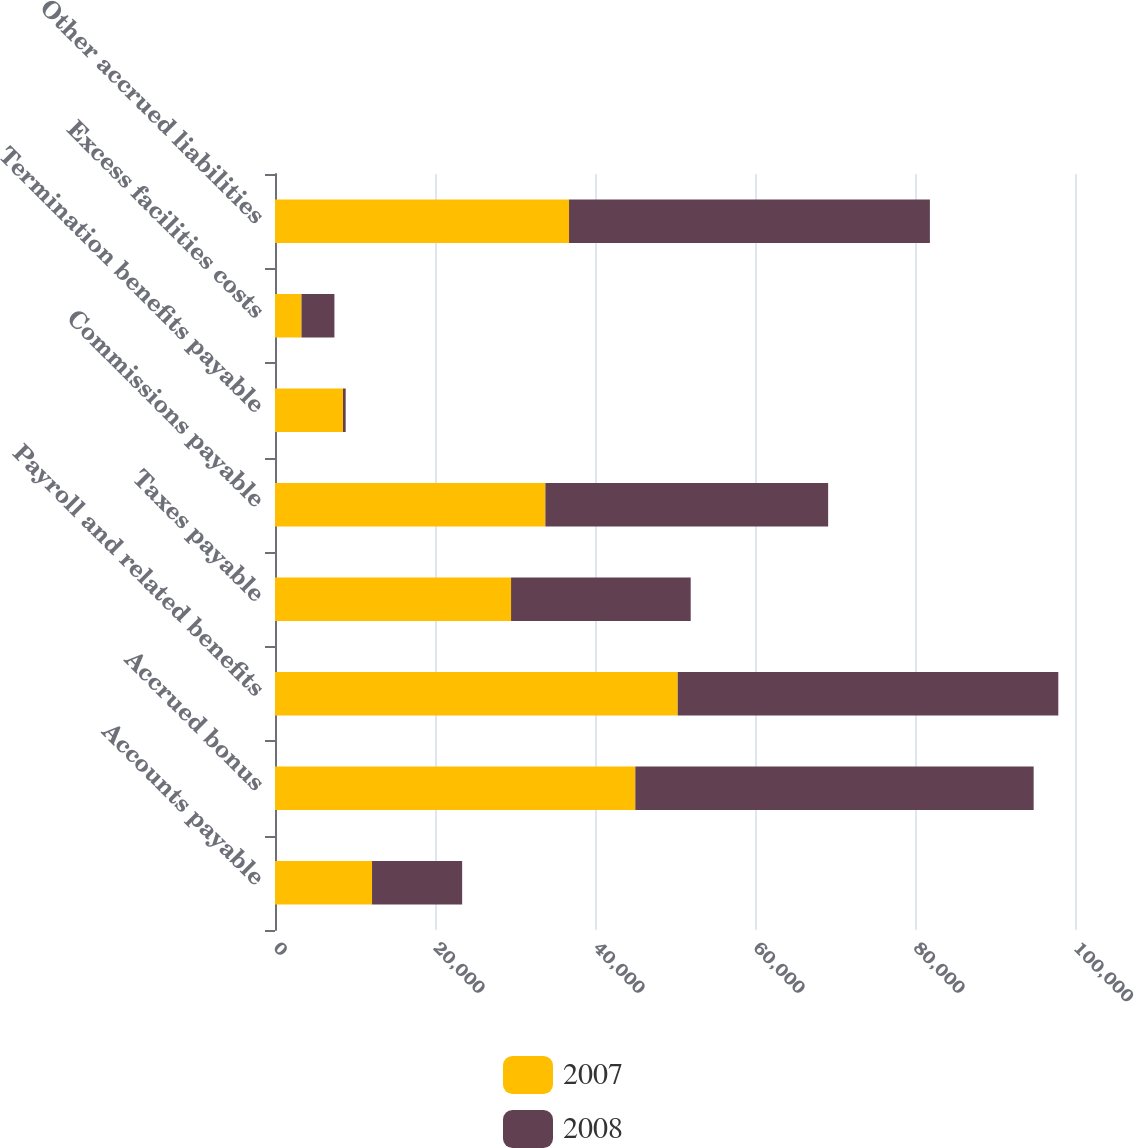Convert chart. <chart><loc_0><loc_0><loc_500><loc_500><stacked_bar_chart><ecel><fcel>Accounts payable<fcel>Accrued bonus<fcel>Payroll and related benefits<fcel>Taxes payable<fcel>Commissions payable<fcel>Termination benefits payable<fcel>Excess facilities costs<fcel>Other accrued liabilities<nl><fcel>2007<fcel>12130<fcel>45040<fcel>50340<fcel>29508<fcel>33797<fcel>8500<fcel>3311<fcel>36755<nl><fcel>2008<fcel>11264<fcel>49792<fcel>47574<fcel>22454<fcel>35347<fcel>336<fcel>4116<fcel>45107<nl></chart> 